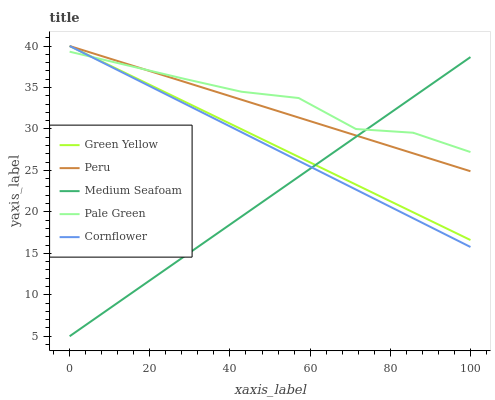Does Green Yellow have the minimum area under the curve?
Answer yes or no. No. Does Green Yellow have the maximum area under the curve?
Answer yes or no. No. Is Green Yellow the smoothest?
Answer yes or no. No. Is Green Yellow the roughest?
Answer yes or no. No. Does Green Yellow have the lowest value?
Answer yes or no. No. Does Medium Seafoam have the highest value?
Answer yes or no. No. 